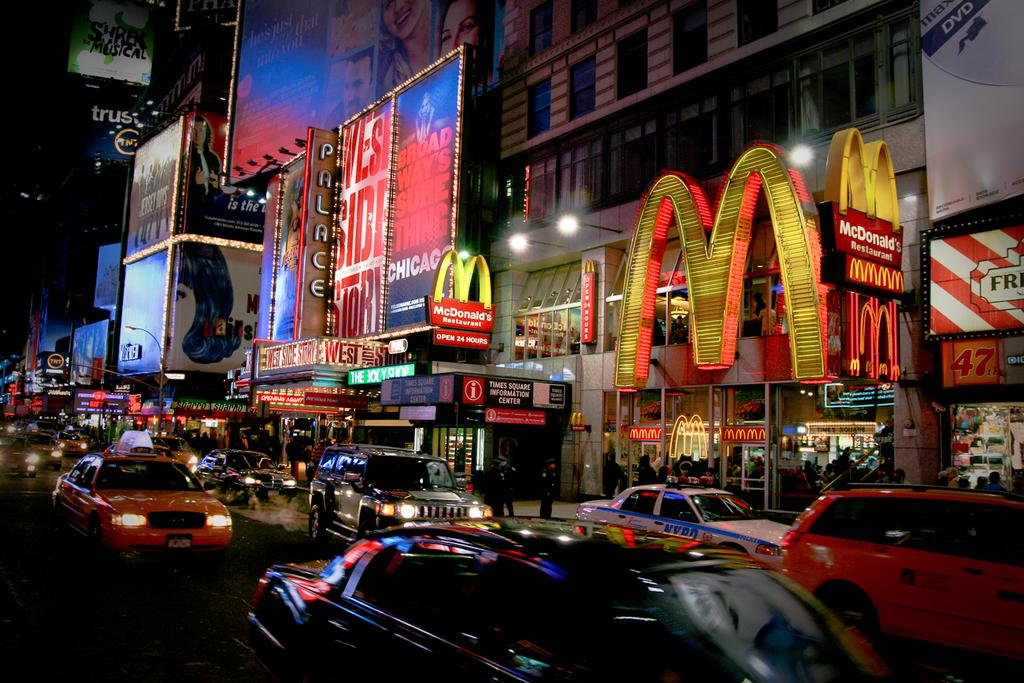Provide a one-sentence caption for the provided image. a street with a large letter M on the side. 